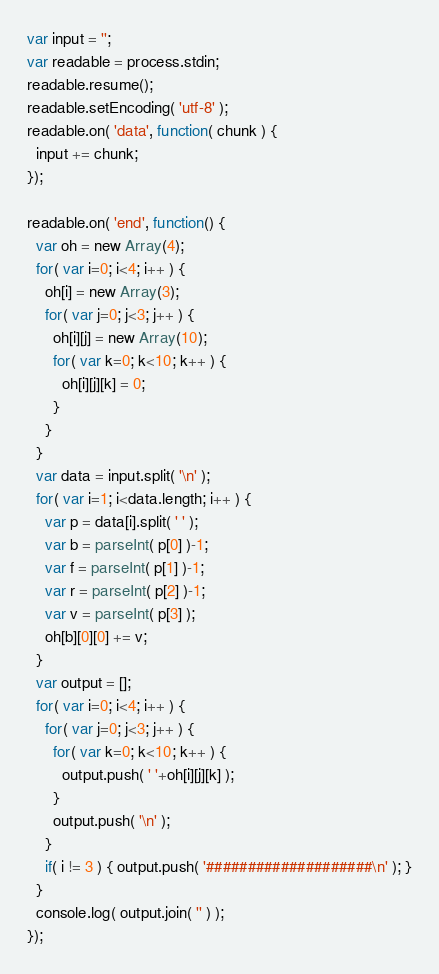<code> <loc_0><loc_0><loc_500><loc_500><_JavaScript_>var input = '';
var readable = process.stdin;
readable.resume();
readable.setEncoding( 'utf-8' );
readable.on( 'data', function( chunk ) {
  input += chunk;
});

readable.on( 'end', function() {
  var oh = new Array(4);
  for( var i=0; i<4; i++ ) {
    oh[i] = new Array(3);
    for( var j=0; j<3; j++ ) {
      oh[i][j] = new Array(10);
      for( var k=0; k<10; k++ ) {
        oh[i][j][k] = 0;
      }
    }
  }
  var data = input.split( '\n' );
  for( var i=1; i<data.length; i++ ) {
    var p = data[i].split( ' ' );
    var b = parseInt( p[0] )-1;
    var f = parseInt( p[1] )-1;
    var r = parseInt( p[2] )-1;
    var v = parseInt( p[3] );    
    oh[b][0][0] += v;
  }
  var output = [];
  for( var i=0; i<4; i++ ) {
    for( var j=0; j<3; j++ ) {
      for( var k=0; k<10; k++ ) {
        output.push( ' '+oh[i][j][k] );
      }
      output.push( '\n' );
    }
    if( i != 3 ) { output.push( '####################\n' ); }
  }
  console.log( output.join( '' ) );
});</code> 